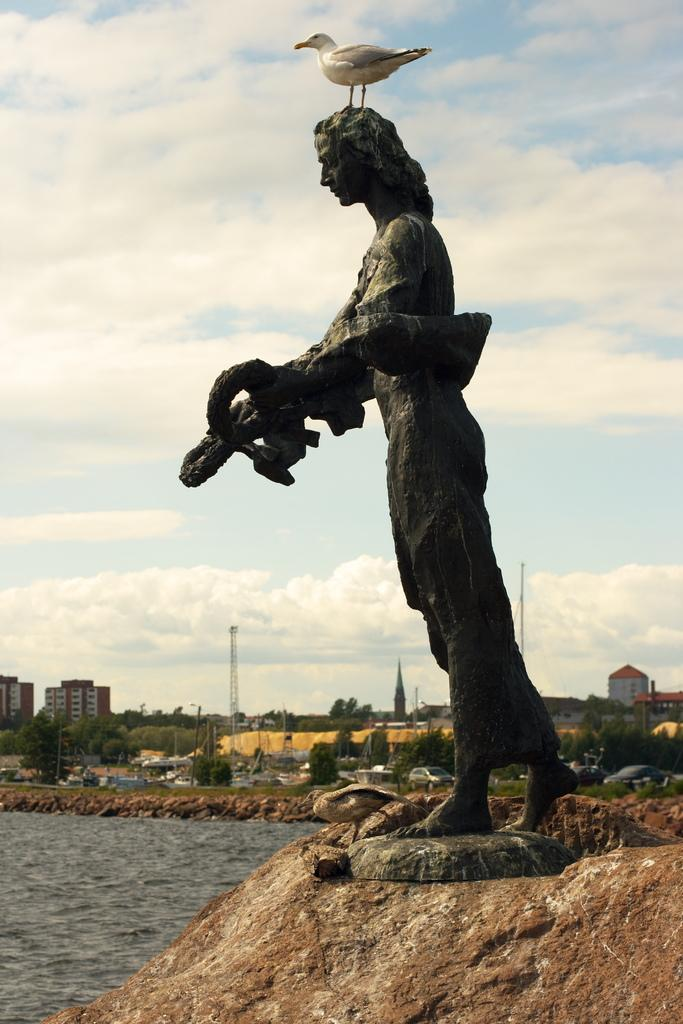What is on the statue in the center of the image? There is a bird on the statue in the center of the image. What is located at the bottom of the image? There is a rock at the bottom of the image. What can be seen in the background of the image? Water, buildings, trees, towers, grass, the sky, and clouds are visible in the background of the image. What type of skin can be seen on the lettuce in the image? There is no lettuce present in the image, so there is no skin to be observed. 